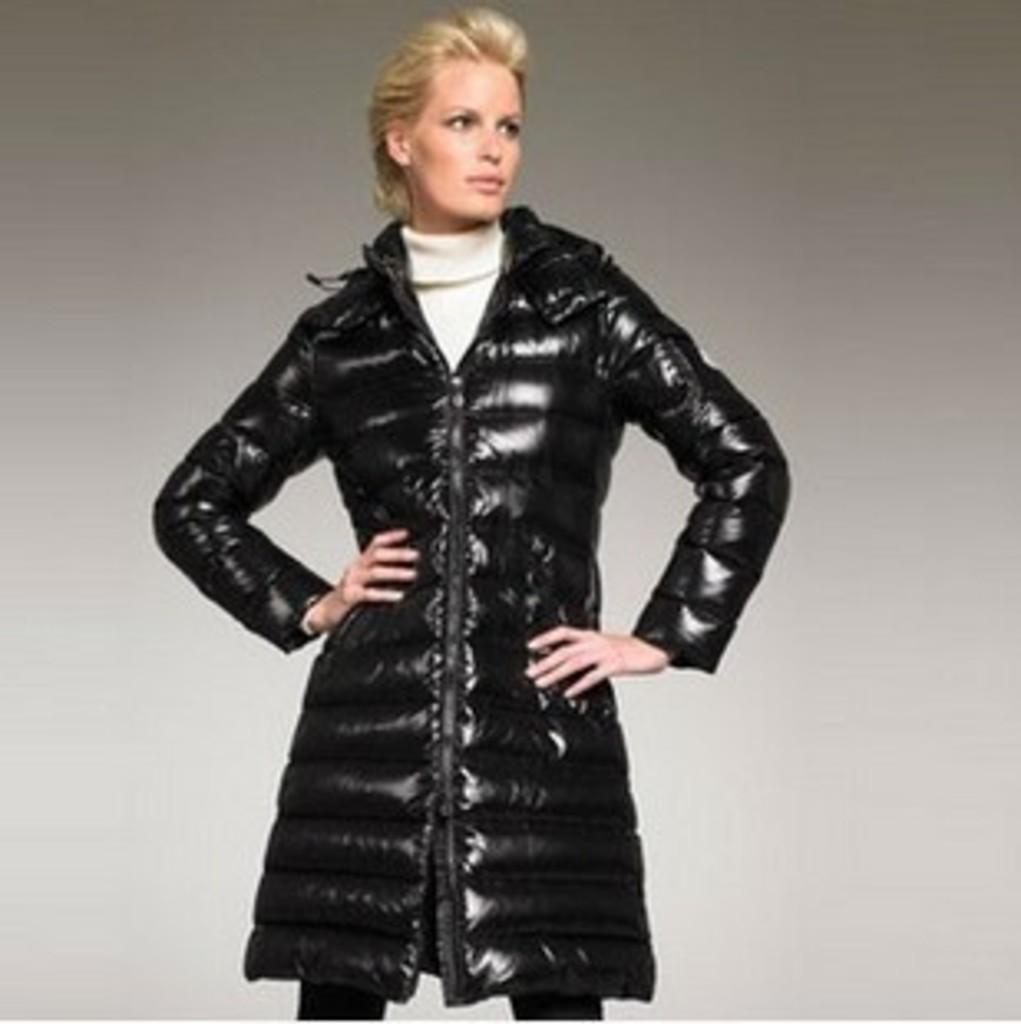Who is present in the image? There is a person in the image. What is the person doing in the image? The person is standing and posing for a photo. What is the person wearing in the image? The person is wearing a black color jacket. What type of shoe is the yak wearing in the image? There is no yak present in the image, and therefore no shoes to describe. 